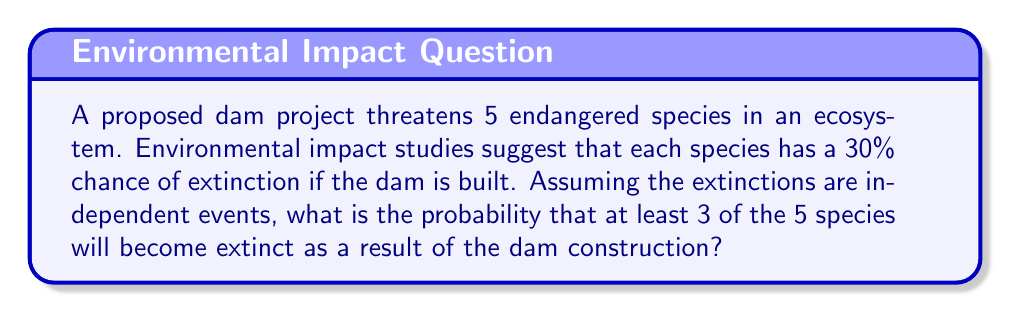Provide a solution to this math problem. Let's approach this step-by-step using combinatorial probability:

1) First, we need to calculate the probability of exactly 3, 4, and 5 species becoming extinct, then sum these probabilities.

2) Let $p$ be the probability of extinction for each species. Given $p = 0.3$ (30%)

3) We can use the binomial probability formula:

   $P(X = k) = \binom{n}{k} p^k (1-p)^{n-k}$

   Where $n$ is the total number of species (5), and $k$ is the number of extinctions.

4) For exactly 3 extinctions:
   $P(X = 3) = \binom{5}{3} (0.3)^3 (0.7)^2$
   $= 10 \times 0.027 \times 0.49 = 0.1323$

5) For exactly 4 extinctions:
   $P(X = 4) = \binom{5}{4} (0.3)^4 (0.7)^1$
   $= 5 \times 0.0081 \times 0.7 = 0.02835$

6) For all 5 extinctions:
   $P(X = 5) = \binom{5}{5} (0.3)^5 (0.7)^0$
   $= 1 \times 0.00243 \times 1 = 0.00243$

7) The probability of at least 3 extinctions is the sum of these probabilities:

   $P(X \geq 3) = P(X = 3) + P(X = 4) + P(X = 5)$
   $= 0.1323 + 0.02835 + 0.00243 = 0.16308$
Answer: $0.16308$ or approximately $16.31\%$ 